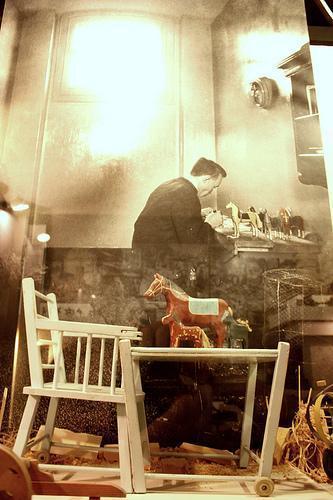How many men are in the photo?
Give a very brief answer. 1. 